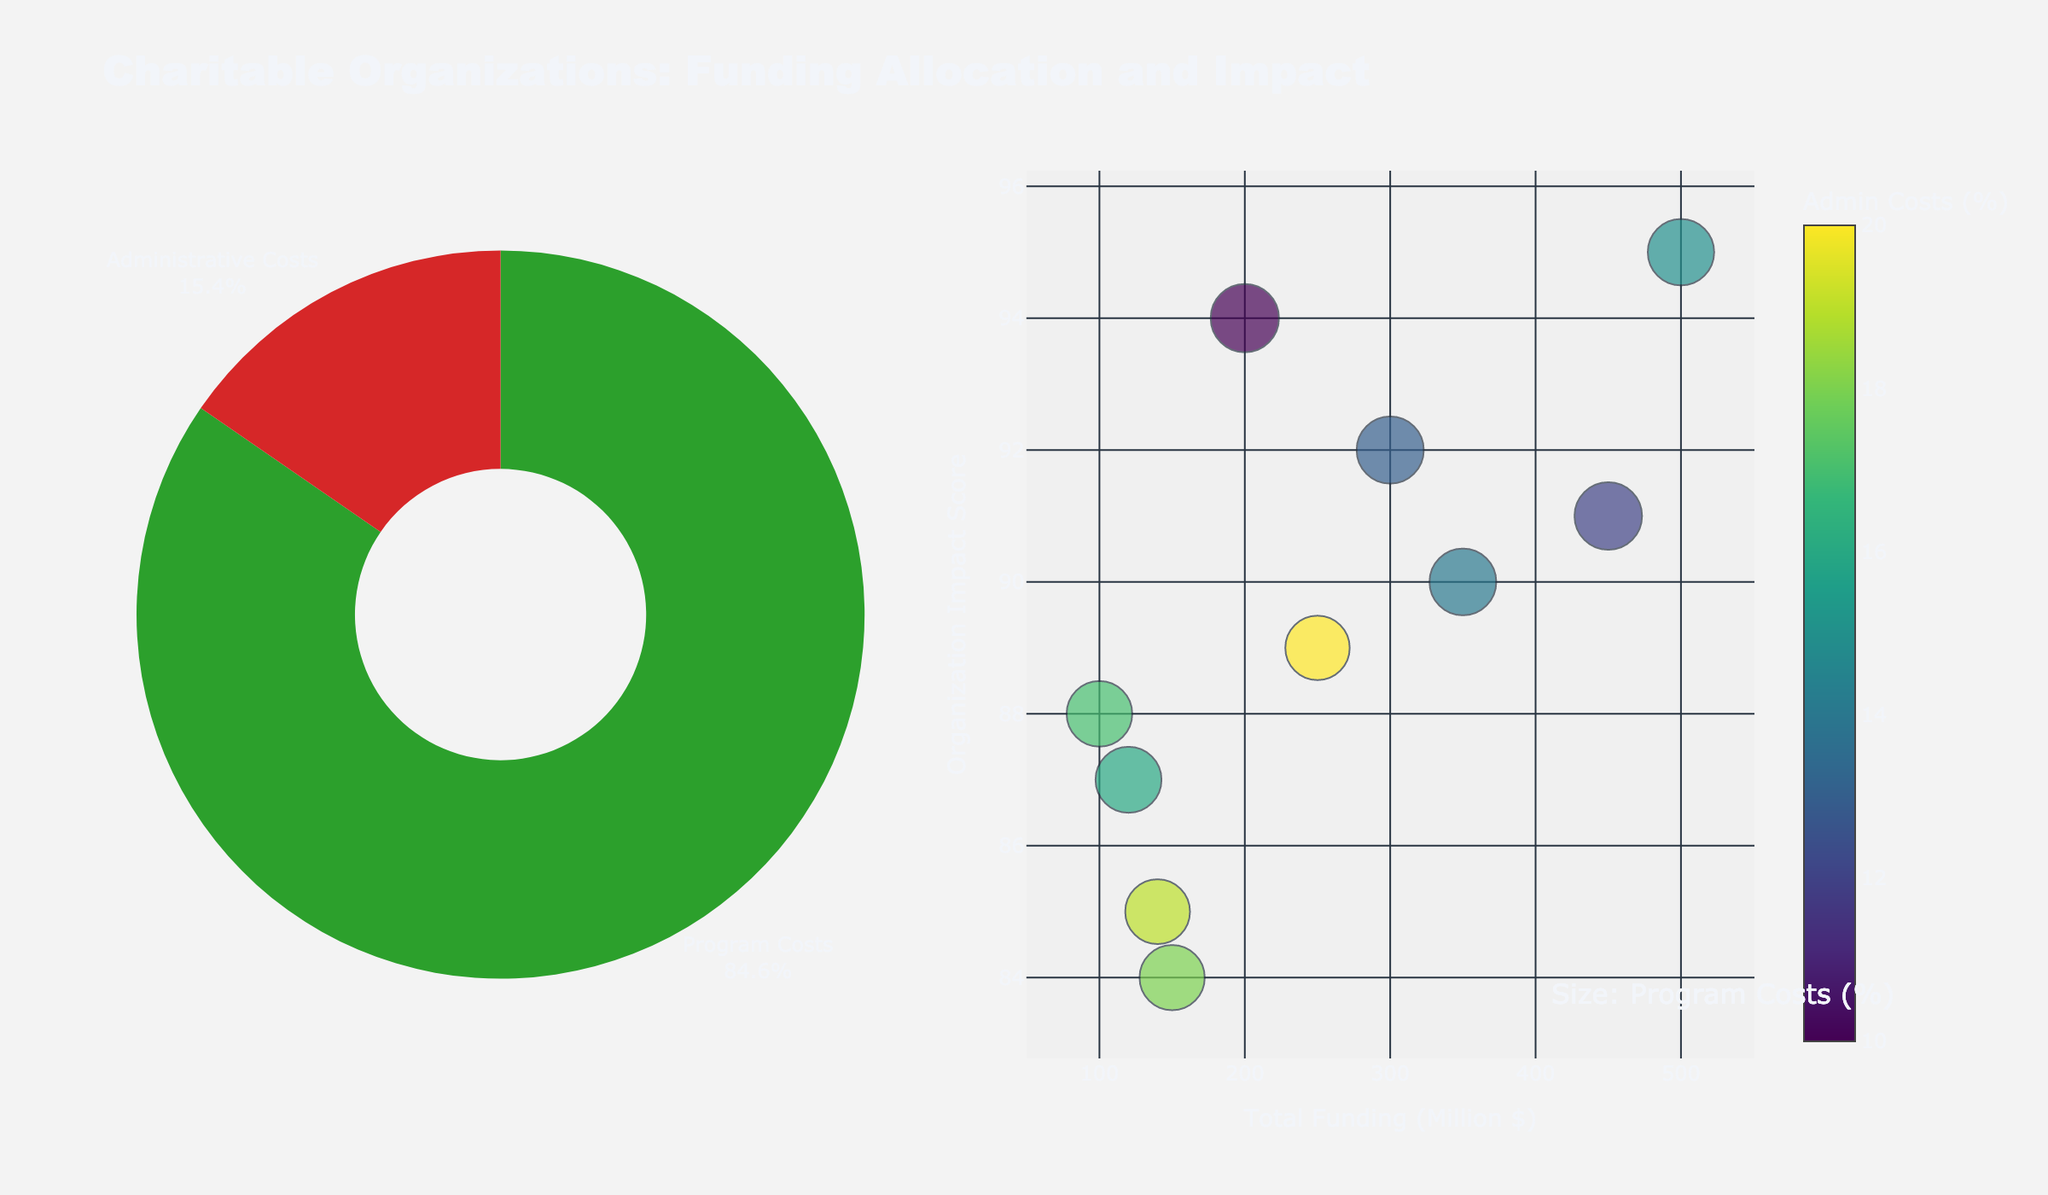What is the title of the plot? The title of the plot is displayed prominently at the top of the figure.
Answer: "Charitable Organizations: Funding Allocation and Impact" What are the labels in the pie chart? The pie chart has two segments, each labeled with the cost type.
Answer: "Program Costs", "Administrative Costs" Which organization has the highest funding? By examining the x-axis of the bubble chart which represents Total Funding, the organization with the farthest right bubble has the highest funding.
Answer: Red Cross How is the Organization Impact Score represented on the plot? The y-axis of the bubble chart represents the Organization Impact Score.
Answer: On the y-axis of the bubble chart Which organization has the highest Program Costs percentage? The size of the bubbles in the bubble chart corresponds to the Program Costs percentage, and the largest bubble represents the highest Program Costs.
Answer: Oxfam What is the color used to represent Administrative Costs in the pie chart? The segment labeled "Administrative Costs" in the pie chart has a specific color.
Answer: Red What is the median Total Funding among all organizations? To find the median Total Funding, list all the funding values, order them, and find the middle value. The values are 100, 120, 140, 150, 200, 250, 300, 350, 450, 500, so the median is the average of the middle two values (200 and 250).
Answer: 225 Million $ Which organizations have an Administrative Costs percentage greater than 15%? Bubbles that are color-coded with shades corresponding to percentages greater than 15% on the color scale indicate these organizations. Habitat for Humanity, Amnesty International, Greenpeace, CARE all have bubbles in this range.
Answer: Habitat for Humanity, Amnesty International, Greenpeace, CARE Among the organizations with funding above 400 Million $, which one has a higher impact score? Only Red Cross and UNICEF have more than 400 Million $ in funding. Compare their impact scores on the y-axis. Red Cross has an impact score of 95, and UNICEF has a score of 91.
Answer: Red Cross What's the average Program Costs percentage across all organizations? Sum all the Program Costs percentages (85 + 87 + 80 + 90 + 88 + 82 + 86 + 83 + 84 + 81) = 846, and divide by the number of organizations (10).
Answer: 84.6% 